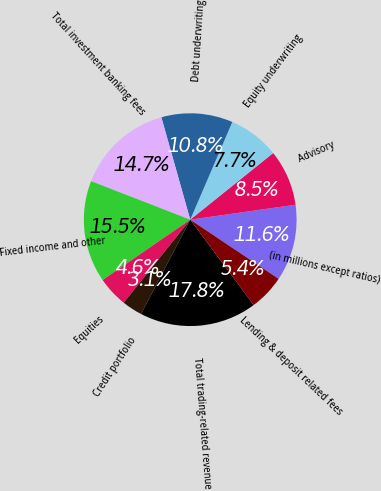Convert chart to OTSL. <chart><loc_0><loc_0><loc_500><loc_500><pie_chart><fcel>(in millions except ratios)<fcel>Advisory<fcel>Equity underwriting<fcel>Debt underwriting<fcel>Total investment banking fees<fcel>Fixed income and other<fcel>Equities<fcel>Credit portfolio<fcel>Total trading-related revenue<fcel>Lending & deposit related fees<nl><fcel>11.63%<fcel>8.53%<fcel>7.75%<fcel>10.85%<fcel>14.73%<fcel>15.5%<fcel>4.65%<fcel>3.1%<fcel>17.83%<fcel>5.43%<nl></chart> 